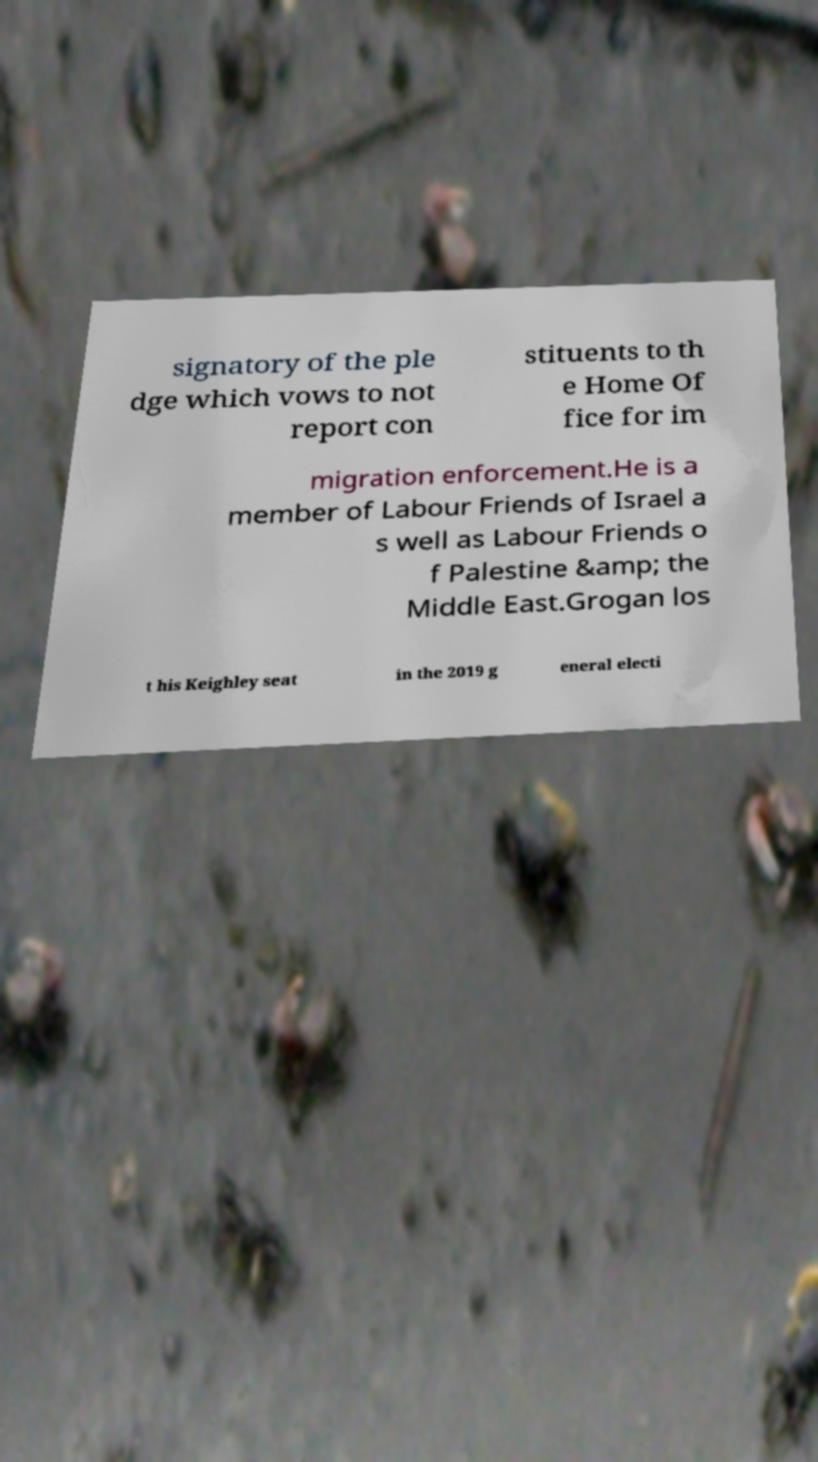Please read and relay the text visible in this image. What does it say? signatory of the ple dge which vows to not report con stituents to th e Home Of fice for im migration enforcement.He is a member of Labour Friends of Israel a s well as Labour Friends o f Palestine &amp; the Middle East.Grogan los t his Keighley seat in the 2019 g eneral electi 